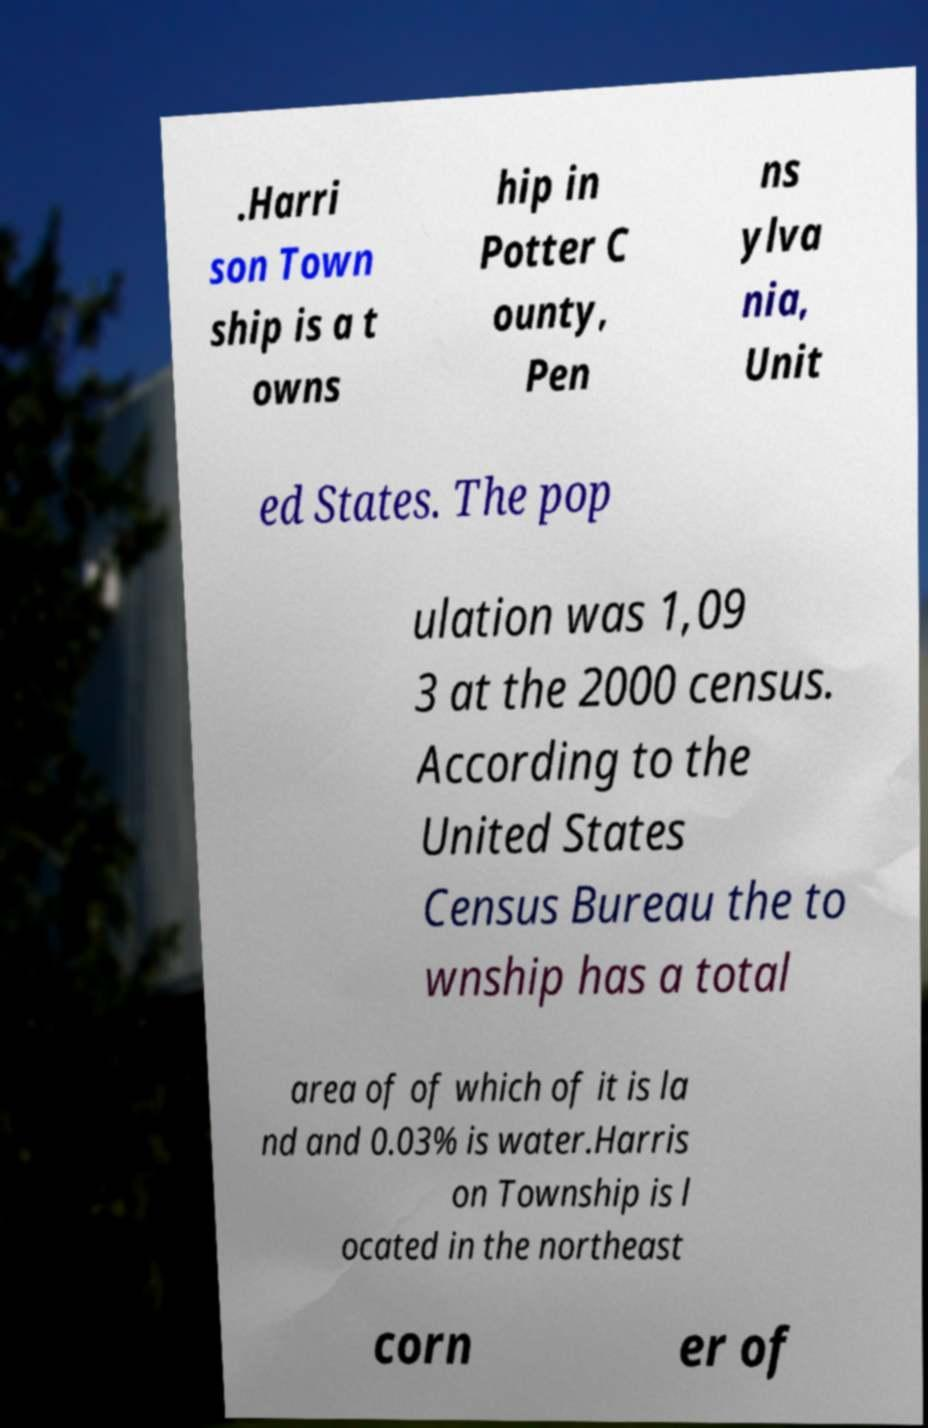Please identify and transcribe the text found in this image. .Harri son Town ship is a t owns hip in Potter C ounty, Pen ns ylva nia, Unit ed States. The pop ulation was 1,09 3 at the 2000 census. According to the United States Census Bureau the to wnship has a total area of of which of it is la nd and 0.03% is water.Harris on Township is l ocated in the northeast corn er of 